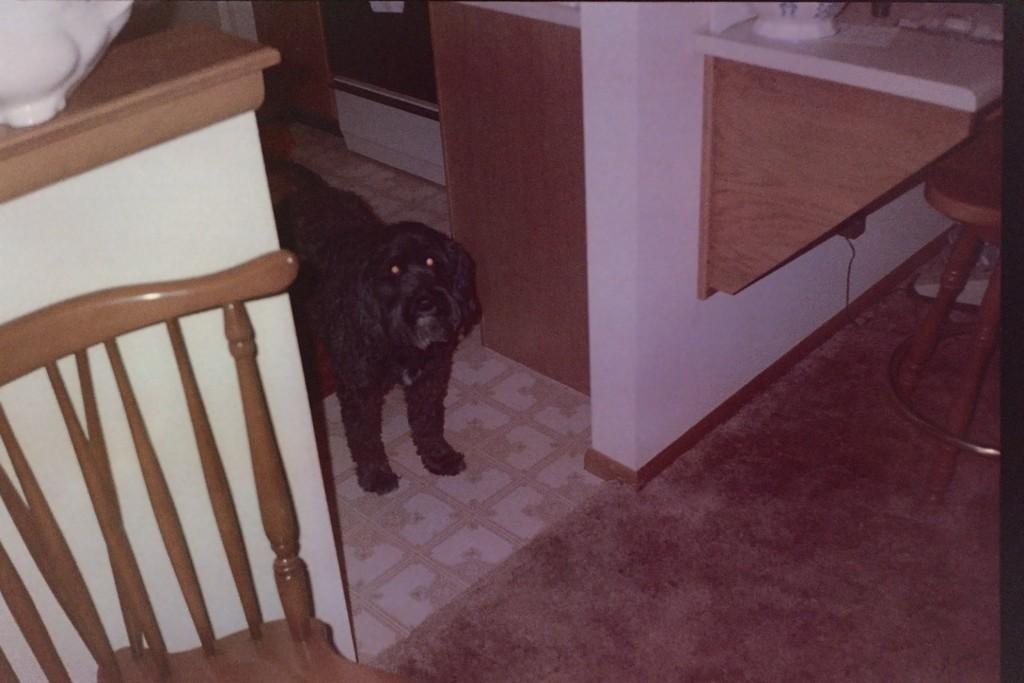What type of furniture is in the image? There is a chair in the image. What type of animal is in the image? There is a dog in the image. What can be seen on the racks in the image? There are objects on the racks in the image. What is visible on the ground in the image? The floor is visible in the image. What type of floor covering is in the image? There is a carpet in the image. What other objects are present in the image? There are additional objects present in the image. What type of blood is visible on the carpet in the image? There is no blood visible on the carpet in the image. What type of request does the manager make in the image? There is no manager or request present in the image. 